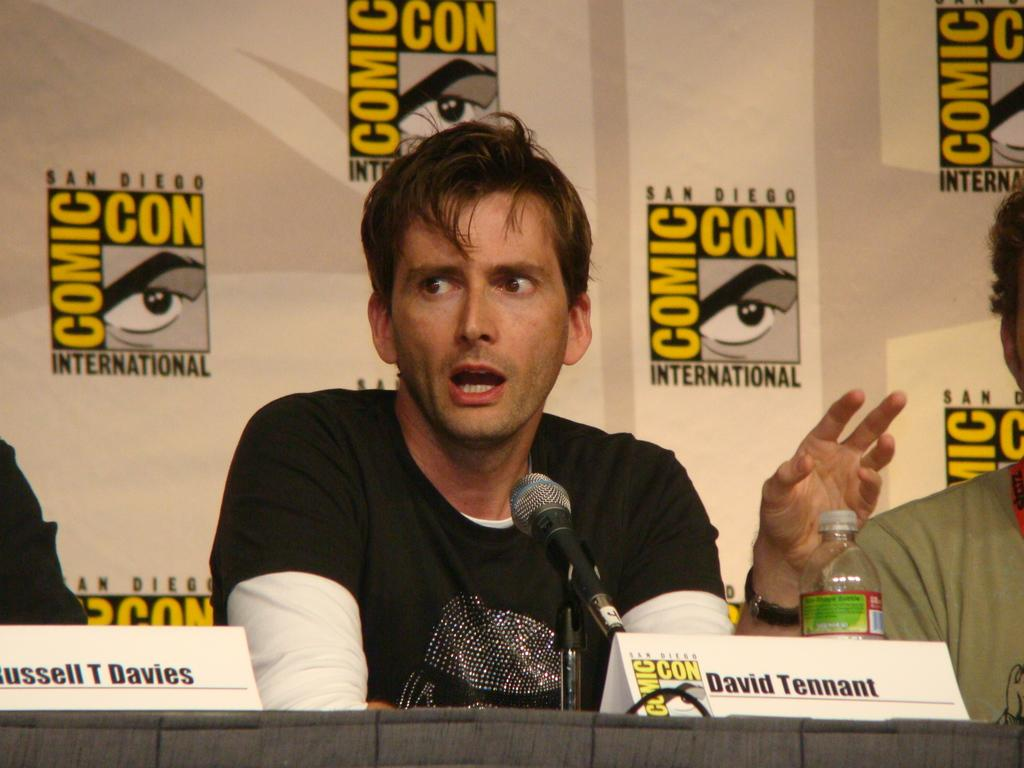What is the man in the image doing? The man is sitting on a chair and talking on a microphone. What object is in front of the man? There is a water bottle in front of the man. What can be seen behind the man? There is a banner behind the man. How many people are beside the man? There are two persons beside the man. What type of spade is the man using to dig a hole in the image? There is no spade or digging activity present in the image. Can you tell me how many pigs are visible in the image? There are no pigs present in the image. 